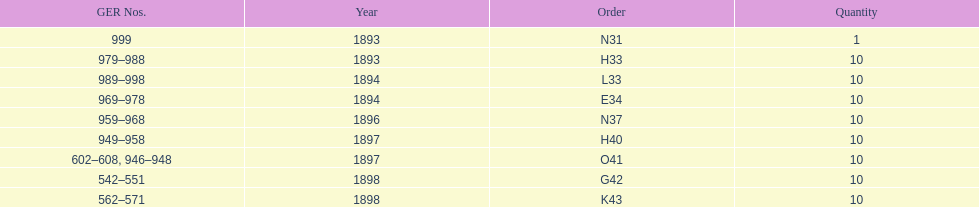Which year had the least ger numbers? 1893. 